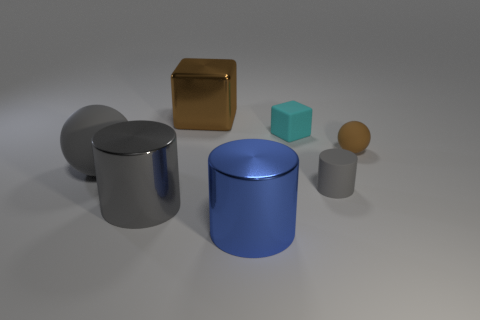There is a gray matte object that is on the right side of the brown metal thing; is its size the same as the small rubber ball?
Give a very brief answer. Yes. How many other objects are the same size as the brown matte ball?
Offer a very short reply. 2. What color is the small rubber cylinder?
Make the answer very short. Gray. What is the material of the large object that is in front of the large gray shiny cylinder?
Provide a short and direct response. Metal. Is the number of large metal objects behind the large gray matte ball the same as the number of small red balls?
Keep it short and to the point. No. Does the blue thing have the same shape as the brown shiny thing?
Provide a succinct answer. No. Is there anything else that is the same color as the big rubber ball?
Offer a terse response. Yes. What is the shape of the gray thing that is both to the left of the small cyan matte cube and on the right side of the big gray sphere?
Offer a very short reply. Cylinder. Is the number of brown cubes behind the big blue metallic cylinder the same as the number of big blue shiny things on the right side of the small sphere?
Provide a short and direct response. No. What number of cylinders are tiny gray shiny objects or large blue objects?
Your answer should be very brief. 1. 